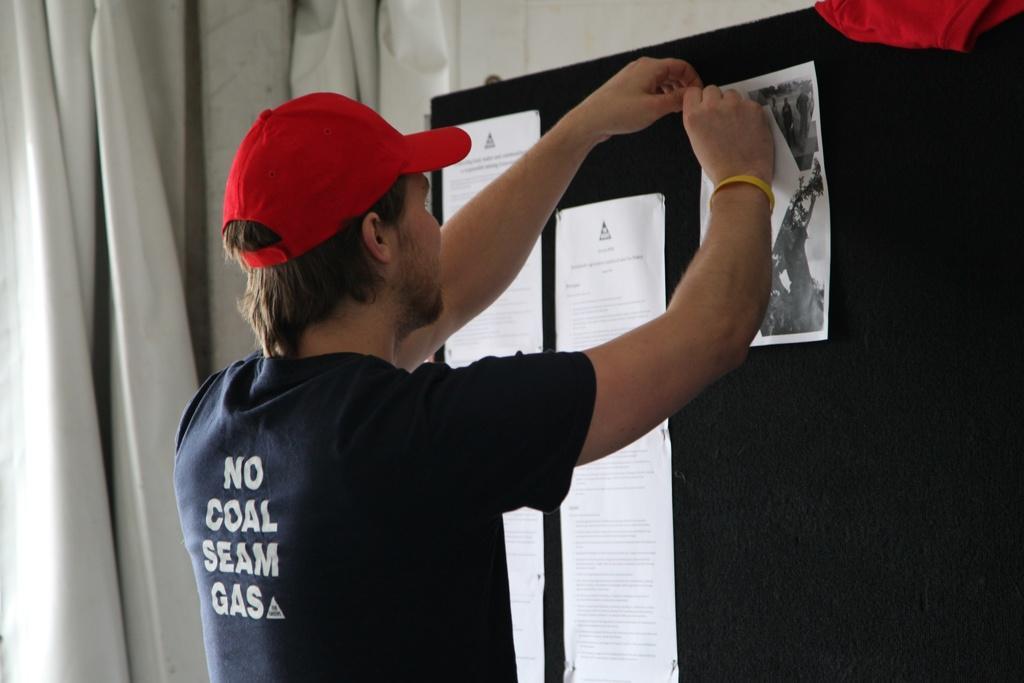Please provide a concise description of this image. In this image I can see a person wearing black t shirt, red cap is standing and holding a paper in his hand. I can see a black colored board in front of him to which I can see few papers are attached. In the background I can see the white colored curtain. 